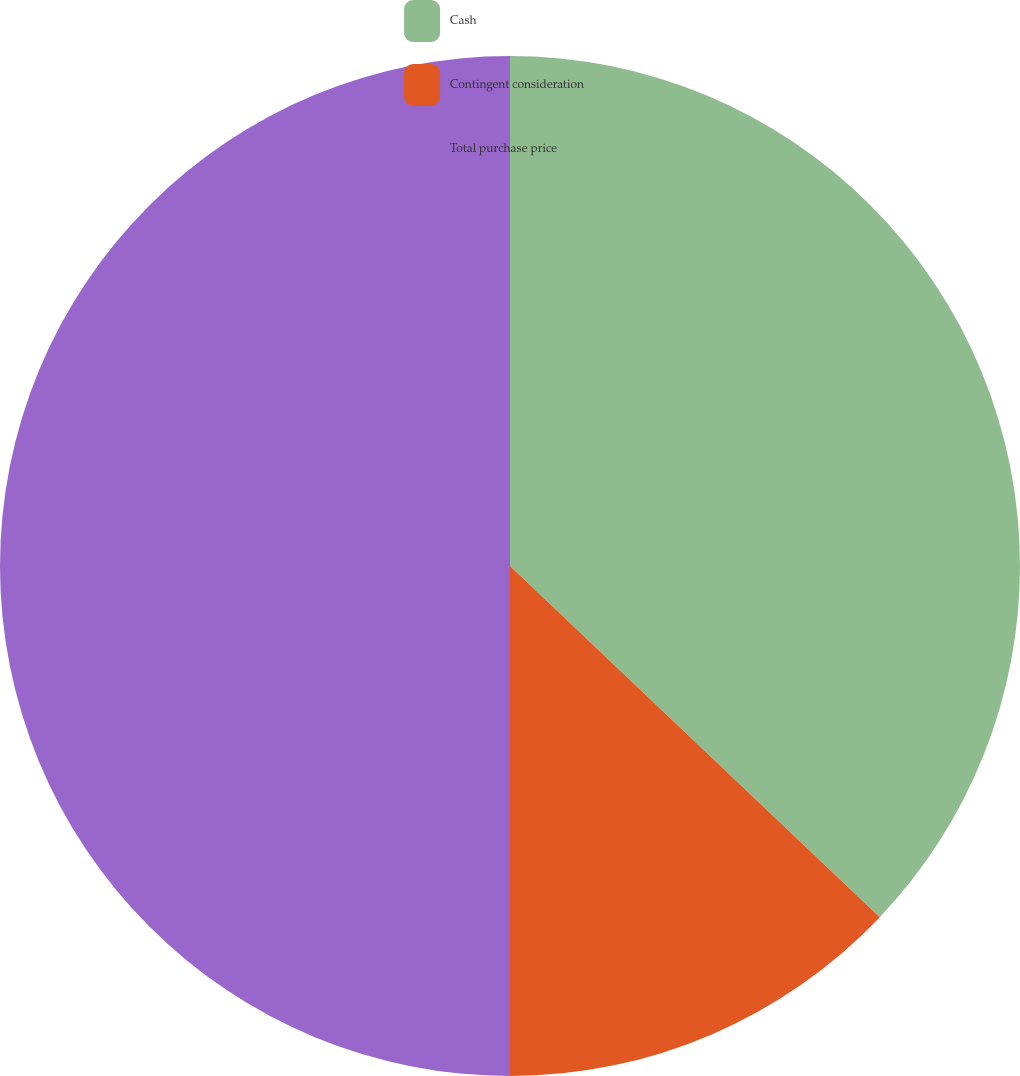Convert chart. <chart><loc_0><loc_0><loc_500><loc_500><pie_chart><fcel>Cash<fcel>Contingent consideration<fcel>Total purchase price<nl><fcel>37.09%<fcel>12.91%<fcel>50.0%<nl></chart> 